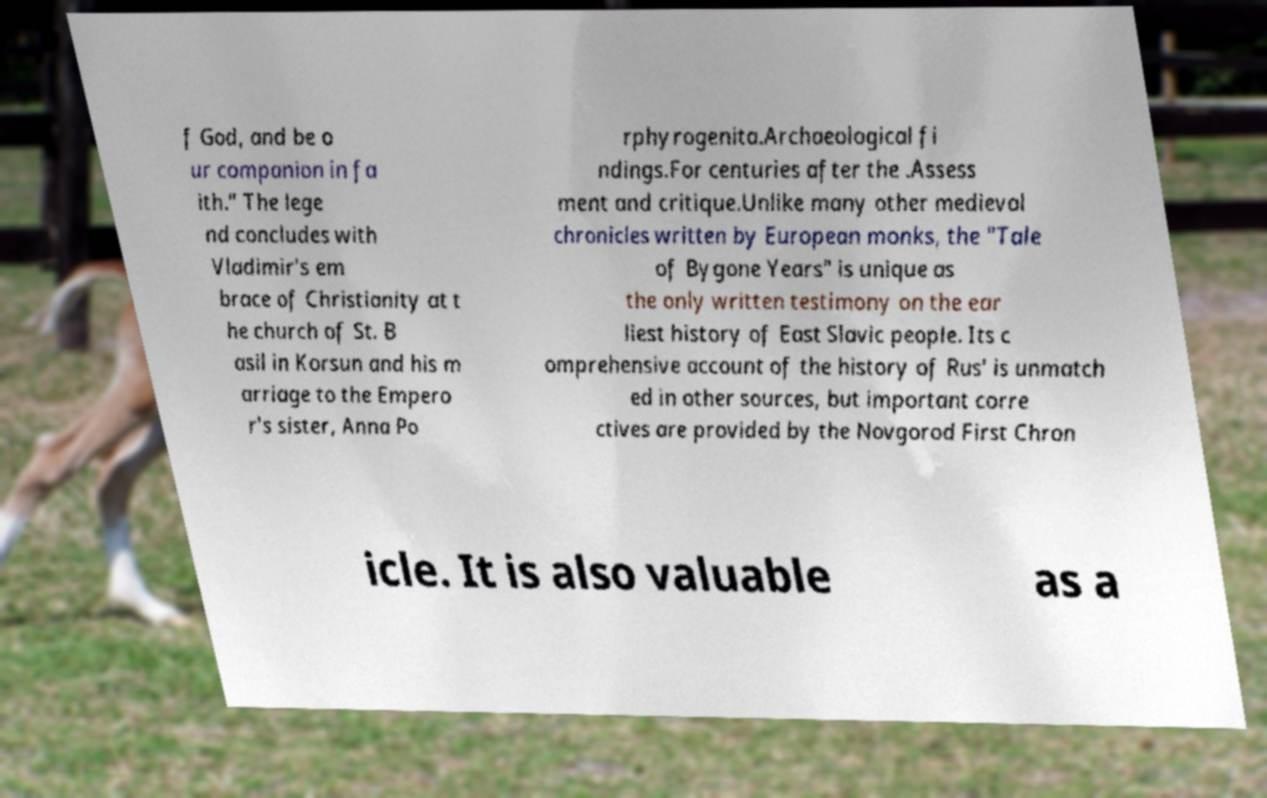Please identify and transcribe the text found in this image. f God, and be o ur companion in fa ith.” The lege nd concludes with Vladimir's em brace of Christianity at t he church of St. B asil in Korsun and his m arriage to the Empero r's sister, Anna Po rphyrogenita.Archaeological fi ndings.For centuries after the .Assess ment and critique.Unlike many other medieval chronicles written by European monks, the "Tale of Bygone Years" is unique as the only written testimony on the ear liest history of East Slavic people. Its c omprehensive account of the history of Rus' is unmatch ed in other sources, but important corre ctives are provided by the Novgorod First Chron icle. It is also valuable as a 